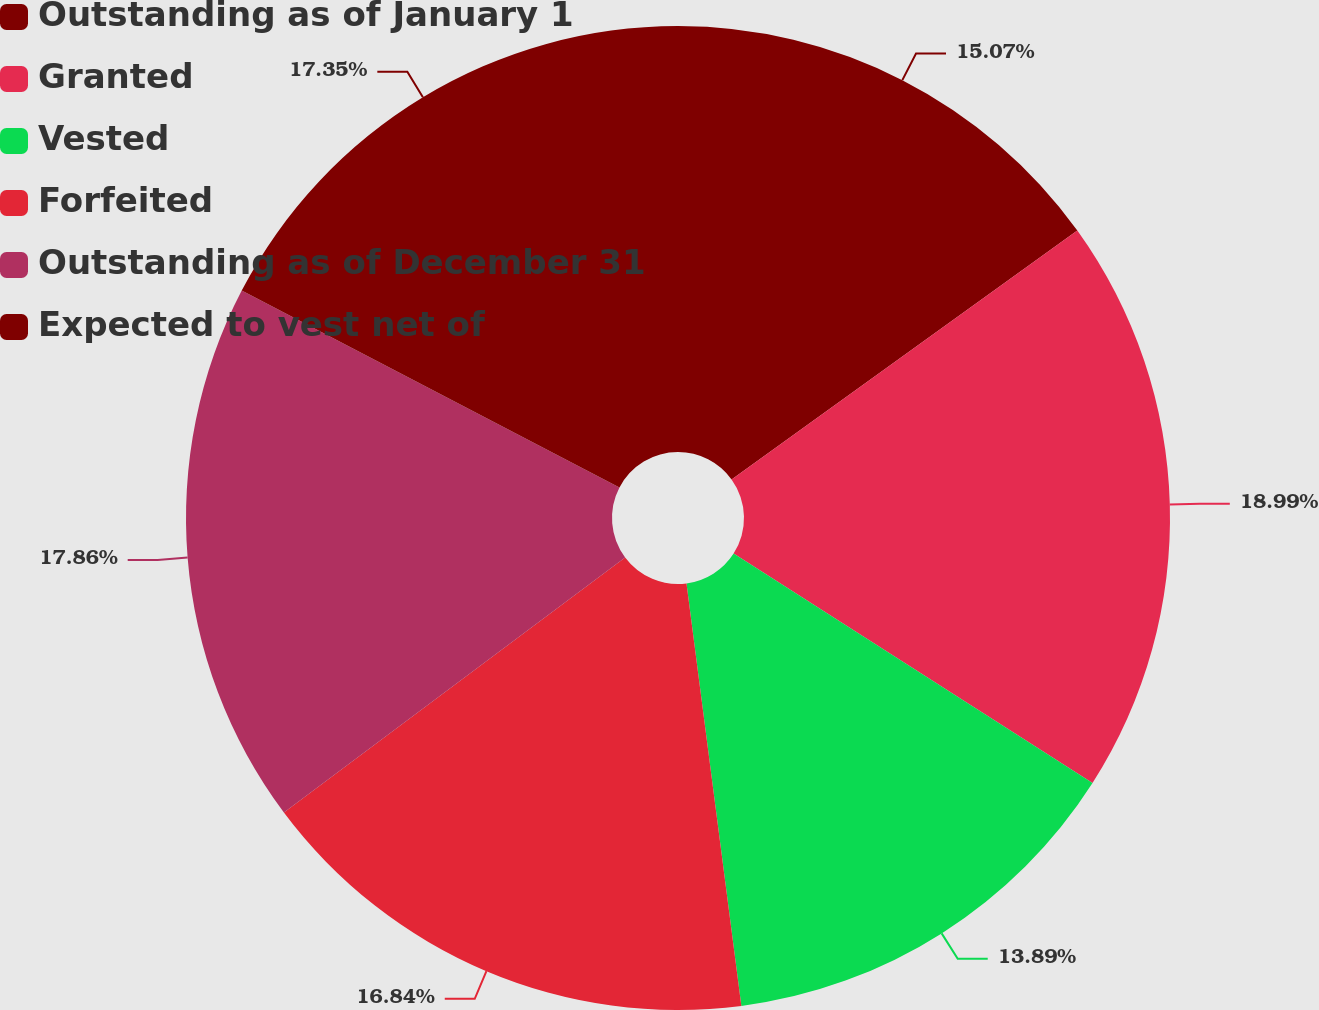<chart> <loc_0><loc_0><loc_500><loc_500><pie_chart><fcel>Outstanding as of January 1<fcel>Granted<fcel>Vested<fcel>Forfeited<fcel>Outstanding as of December 31<fcel>Expected to vest net of<nl><fcel>15.07%<fcel>18.98%<fcel>13.89%<fcel>16.84%<fcel>17.86%<fcel>17.35%<nl></chart> 